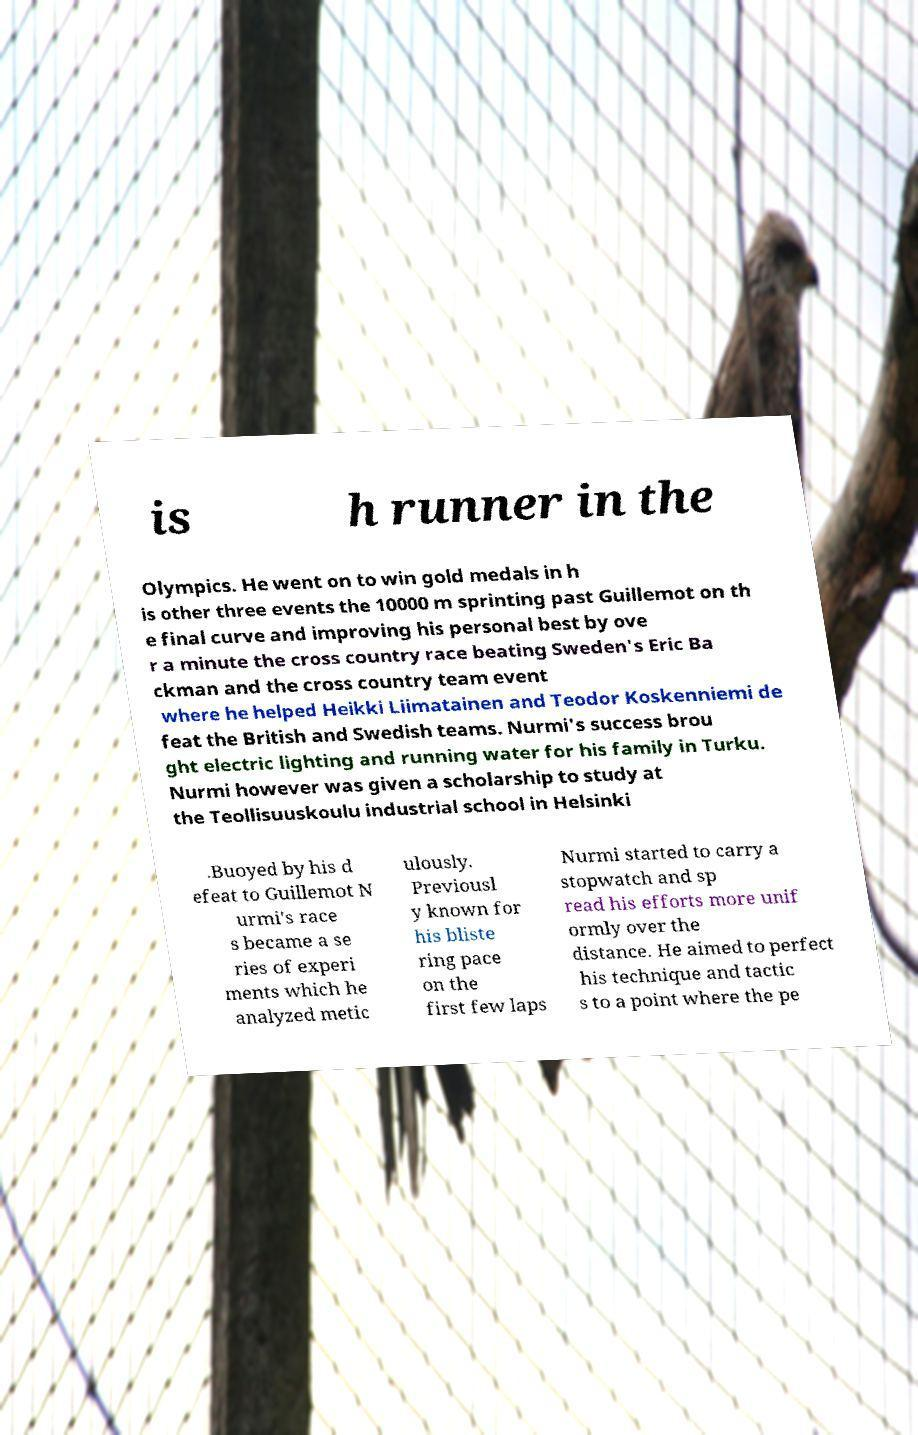What messages or text are displayed in this image? I need them in a readable, typed format. is h runner in the Olympics. He went on to win gold medals in h is other three events the 10000 m sprinting past Guillemot on th e final curve and improving his personal best by ove r a minute the cross country race beating Sweden's Eric Ba ckman and the cross country team event where he helped Heikki Liimatainen and Teodor Koskenniemi de feat the British and Swedish teams. Nurmi's success brou ght electric lighting and running water for his family in Turku. Nurmi however was given a scholarship to study at the Teollisuuskoulu industrial school in Helsinki .Buoyed by his d efeat to Guillemot N urmi's race s became a se ries of experi ments which he analyzed metic ulously. Previousl y known for his bliste ring pace on the first few laps Nurmi started to carry a stopwatch and sp read his efforts more unif ormly over the distance. He aimed to perfect his technique and tactic s to a point where the pe 